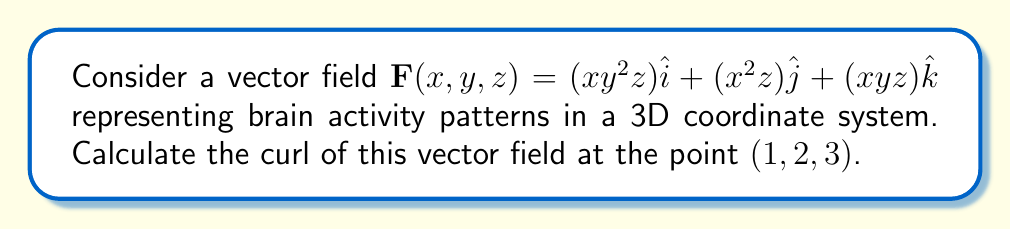Teach me how to tackle this problem. To find the curl of the vector field, we need to follow these steps:

1. Recall the formula for curl in 3D:
   $$\text{curl }\mathbf{F} = \nabla \times \mathbf{F} = \left(\frac{\partial F_z}{\partial y} - \frac{\partial F_y}{\partial z}\right)\hat{i} + \left(\frac{\partial F_x}{\partial z} - \frac{\partial F_z}{\partial x}\right)\hat{j} + \left(\frac{\partial F_y}{\partial x} - \frac{\partial F_x}{\partial y}\right)\hat{k}$$

2. Identify the components of $\mathbf{F}$:
   $F_x = xy^2z$
   $F_y = x^2z$
   $F_z = xyz$

3. Calculate the partial derivatives:
   $\frac{\partial F_z}{\partial y} = xz$
   $\frac{\partial F_y}{\partial z} = x^2$
   $\frac{\partial F_x}{\partial z} = xy^2$
   $\frac{\partial F_z}{\partial x} = yz$
   $\frac{\partial F_y}{\partial x} = 2xz$
   $\frac{\partial F_x}{\partial y} = 2xyz$

4. Substitute these values into the curl formula:
   $$\text{curl }\mathbf{F} = (xz - x^2)\hat{i} + (xy^2 - yz)\hat{j} + (2xz - 2xyz)\hat{k}$$

5. Evaluate at the point $(1,2,3)$:
   $$\text{curl }\mathbf{F}(1,2,3) = (3 - 1)\hat{i} + (12 - 6)\hat{j} + (6 - 12)\hat{k}$$

6. Simplify:
   $$\text{curl }\mathbf{F}(1,2,3) = 2\hat{i} + 6\hat{j} - 6\hat{k}$$
Answer: $2\hat{i} + 6\hat{j} - 6\hat{k}$ 